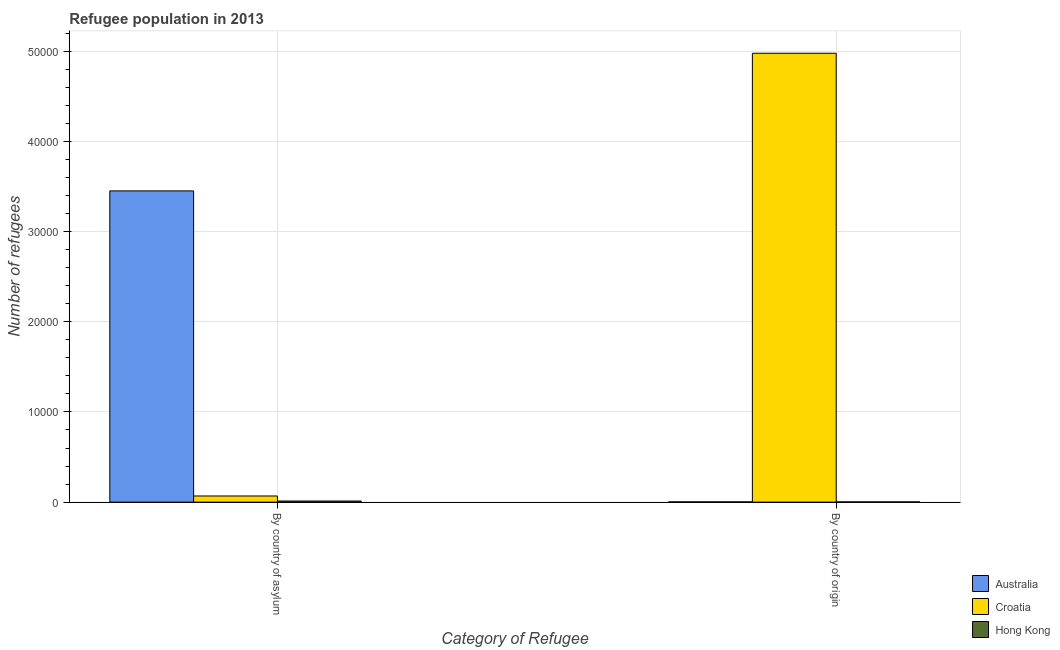How many different coloured bars are there?
Offer a terse response. 3. Are the number of bars per tick equal to the number of legend labels?
Your response must be concise. Yes. How many bars are there on the 1st tick from the left?
Make the answer very short. 3. What is the label of the 2nd group of bars from the left?
Make the answer very short. By country of origin. What is the number of refugees by country of asylum in Croatia?
Your answer should be compact. 684. Across all countries, what is the maximum number of refugees by country of asylum?
Give a very brief answer. 3.45e+04. Across all countries, what is the minimum number of refugees by country of asylum?
Ensure brevity in your answer.  126. In which country was the number of refugees by country of origin maximum?
Your answer should be very brief. Croatia. In which country was the number of refugees by country of origin minimum?
Provide a short and direct response. Hong Kong. What is the total number of refugees by country of asylum in the graph?
Make the answer very short. 3.53e+04. What is the difference between the number of refugees by country of origin in Australia and that in Croatia?
Offer a terse response. -4.97e+04. What is the difference between the number of refugees by country of origin in Hong Kong and the number of refugees by country of asylum in Croatia?
Your answer should be compact. -659. What is the average number of refugees by country of asylum per country?
Provide a succinct answer. 1.18e+04. What is the difference between the number of refugees by country of origin and number of refugees by country of asylum in Australia?
Keep it short and to the point. -3.45e+04. What is the ratio of the number of refugees by country of origin in Croatia to that in Australia?
Offer a terse response. 1777.14. Is the number of refugees by country of asylum in Australia less than that in Croatia?
Your answer should be very brief. No. In how many countries, is the number of refugees by country of origin greater than the average number of refugees by country of origin taken over all countries?
Keep it short and to the point. 1. What does the 2nd bar from the right in By country of origin represents?
Offer a very short reply. Croatia. How many bars are there?
Ensure brevity in your answer.  6. Are all the bars in the graph horizontal?
Your answer should be compact. No. How many countries are there in the graph?
Provide a succinct answer. 3. What is the difference between two consecutive major ticks on the Y-axis?
Your response must be concise. 10000. Does the graph contain any zero values?
Your response must be concise. No. How are the legend labels stacked?
Your answer should be very brief. Vertical. What is the title of the graph?
Provide a short and direct response. Refugee population in 2013. What is the label or title of the X-axis?
Offer a terse response. Category of Refugee. What is the label or title of the Y-axis?
Make the answer very short. Number of refugees. What is the Number of refugees of Australia in By country of asylum?
Keep it short and to the point. 3.45e+04. What is the Number of refugees of Croatia in By country of asylum?
Offer a very short reply. 684. What is the Number of refugees in Hong Kong in By country of asylum?
Your answer should be compact. 126. What is the Number of refugees in Croatia in By country of origin?
Give a very brief answer. 4.98e+04. Across all Category of Refugee, what is the maximum Number of refugees in Australia?
Provide a succinct answer. 3.45e+04. Across all Category of Refugee, what is the maximum Number of refugees of Croatia?
Offer a terse response. 4.98e+04. Across all Category of Refugee, what is the maximum Number of refugees of Hong Kong?
Give a very brief answer. 126. Across all Category of Refugee, what is the minimum Number of refugees of Croatia?
Ensure brevity in your answer.  684. Across all Category of Refugee, what is the minimum Number of refugees in Hong Kong?
Provide a short and direct response. 25. What is the total Number of refugees of Australia in the graph?
Provide a short and direct response. 3.45e+04. What is the total Number of refugees of Croatia in the graph?
Give a very brief answer. 5.04e+04. What is the total Number of refugees of Hong Kong in the graph?
Provide a short and direct response. 151. What is the difference between the Number of refugees of Australia in By country of asylum and that in By country of origin?
Provide a short and direct response. 3.45e+04. What is the difference between the Number of refugees of Croatia in By country of asylum and that in By country of origin?
Make the answer very short. -4.91e+04. What is the difference between the Number of refugees in Hong Kong in By country of asylum and that in By country of origin?
Provide a succinct answer. 101. What is the difference between the Number of refugees in Australia in By country of asylum and the Number of refugees in Croatia in By country of origin?
Your response must be concise. -1.53e+04. What is the difference between the Number of refugees of Australia in By country of asylum and the Number of refugees of Hong Kong in By country of origin?
Offer a terse response. 3.45e+04. What is the difference between the Number of refugees in Croatia in By country of asylum and the Number of refugees in Hong Kong in By country of origin?
Offer a terse response. 659. What is the average Number of refugees in Australia per Category of Refugee?
Give a very brief answer. 1.73e+04. What is the average Number of refugees of Croatia per Category of Refugee?
Offer a terse response. 2.52e+04. What is the average Number of refugees of Hong Kong per Category of Refugee?
Give a very brief answer. 75.5. What is the difference between the Number of refugees of Australia and Number of refugees of Croatia in By country of asylum?
Your answer should be compact. 3.38e+04. What is the difference between the Number of refugees of Australia and Number of refugees of Hong Kong in By country of asylum?
Your answer should be compact. 3.44e+04. What is the difference between the Number of refugees of Croatia and Number of refugees of Hong Kong in By country of asylum?
Make the answer very short. 558. What is the difference between the Number of refugees of Australia and Number of refugees of Croatia in By country of origin?
Your answer should be compact. -4.97e+04. What is the difference between the Number of refugees in Croatia and Number of refugees in Hong Kong in By country of origin?
Your answer should be compact. 4.97e+04. What is the ratio of the Number of refugees of Australia in By country of asylum to that in By country of origin?
Offer a very short reply. 1232.25. What is the ratio of the Number of refugees of Croatia in By country of asylum to that in By country of origin?
Your answer should be very brief. 0.01. What is the ratio of the Number of refugees in Hong Kong in By country of asylum to that in By country of origin?
Keep it short and to the point. 5.04. What is the difference between the highest and the second highest Number of refugees in Australia?
Make the answer very short. 3.45e+04. What is the difference between the highest and the second highest Number of refugees in Croatia?
Give a very brief answer. 4.91e+04. What is the difference between the highest and the second highest Number of refugees of Hong Kong?
Provide a short and direct response. 101. What is the difference between the highest and the lowest Number of refugees in Australia?
Give a very brief answer. 3.45e+04. What is the difference between the highest and the lowest Number of refugees of Croatia?
Your response must be concise. 4.91e+04. What is the difference between the highest and the lowest Number of refugees of Hong Kong?
Offer a terse response. 101. 